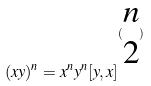Convert formula to latex. <formula><loc_0><loc_0><loc_500><loc_500>( x y ) ^ { n } = x ^ { n } y ^ { n } [ y , x ] ^ { ( \begin{matrix} n \\ 2 \end{matrix} ) }</formula> 